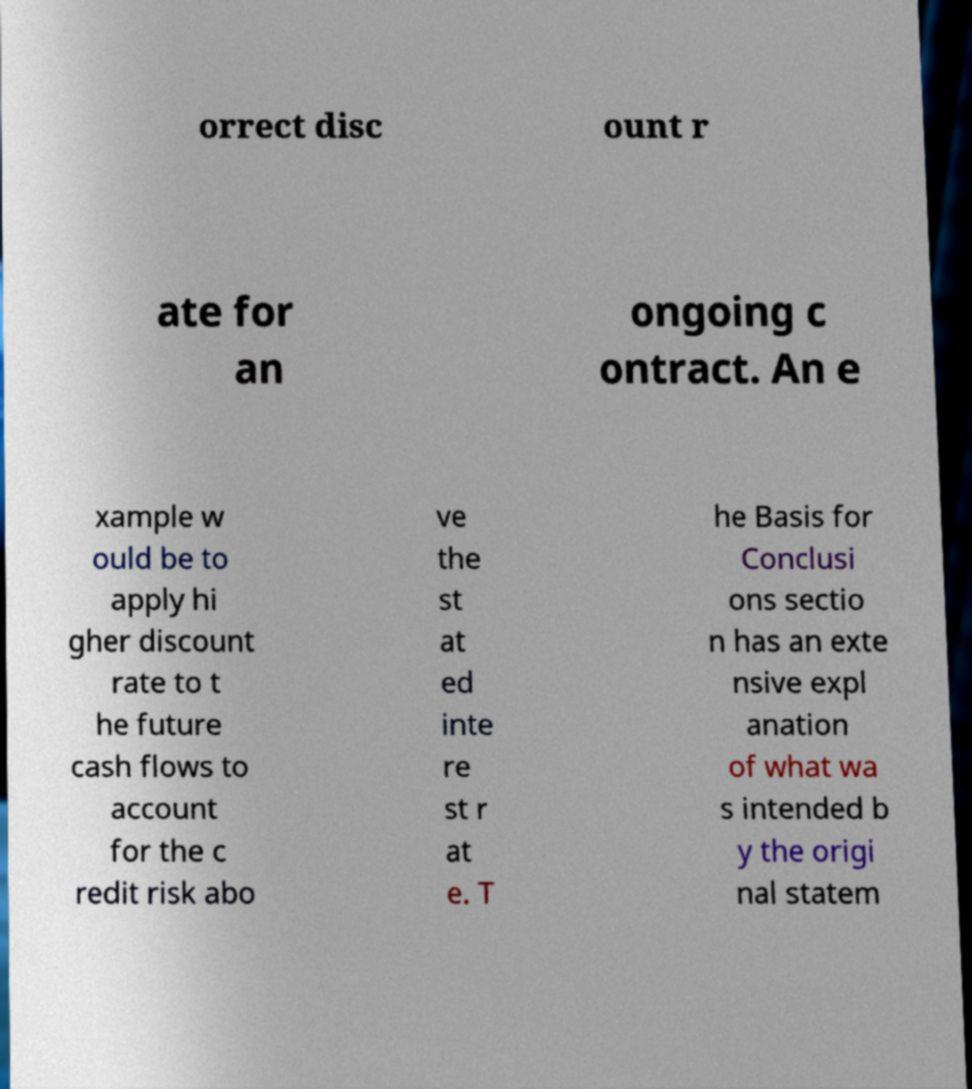What messages or text are displayed in this image? I need them in a readable, typed format. orrect disc ount r ate for an ongoing c ontract. An e xample w ould be to apply hi gher discount rate to t he future cash flows to account for the c redit risk abo ve the st at ed inte re st r at e. T he Basis for Conclusi ons sectio n has an exte nsive expl anation of what wa s intended b y the origi nal statem 